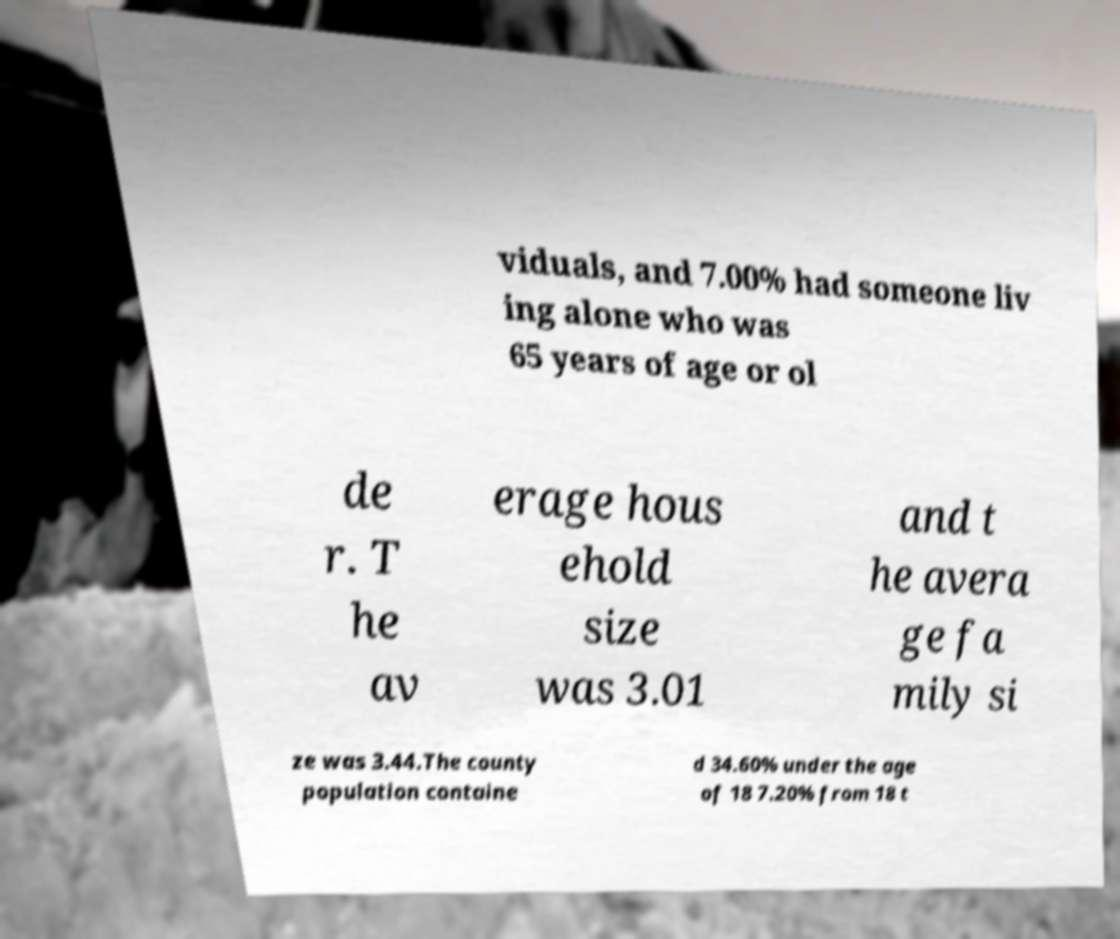Could you extract and type out the text from this image? viduals, and 7.00% had someone liv ing alone who was 65 years of age or ol de r. T he av erage hous ehold size was 3.01 and t he avera ge fa mily si ze was 3.44.The county population containe d 34.60% under the age of 18 7.20% from 18 t 